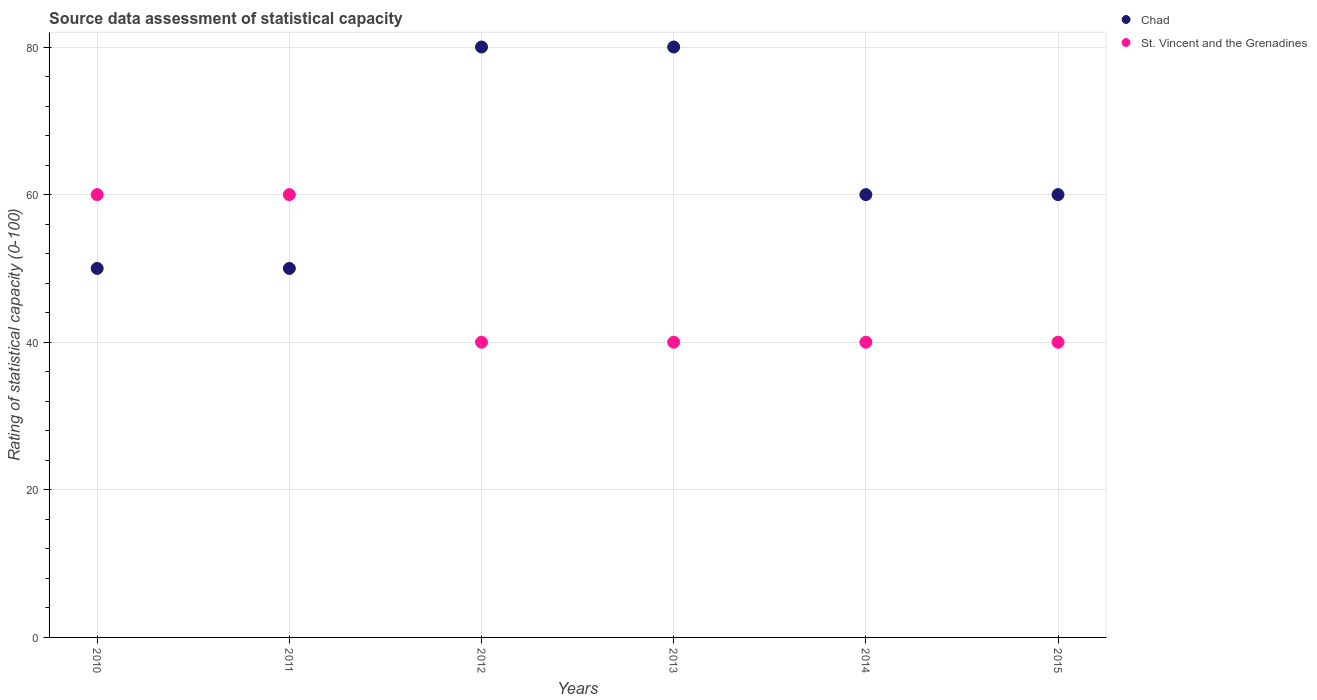Is the number of dotlines equal to the number of legend labels?
Give a very brief answer. Yes. Across all years, what is the maximum rating of statistical capacity in Chad?
Offer a very short reply. 80. Across all years, what is the minimum rating of statistical capacity in Chad?
Make the answer very short. 50. In which year was the rating of statistical capacity in St. Vincent and the Grenadines maximum?
Give a very brief answer. 2010. In which year was the rating of statistical capacity in St. Vincent and the Grenadines minimum?
Give a very brief answer. 2012. What is the total rating of statistical capacity in Chad in the graph?
Give a very brief answer. 380. What is the difference between the rating of statistical capacity in Chad in 2010 and that in 2012?
Offer a terse response. -30. What is the difference between the rating of statistical capacity in St. Vincent and the Grenadines in 2011 and the rating of statistical capacity in Chad in 2010?
Provide a short and direct response. 10. What is the average rating of statistical capacity in Chad per year?
Ensure brevity in your answer.  63.33. In the year 2012, what is the difference between the rating of statistical capacity in Chad and rating of statistical capacity in St. Vincent and the Grenadines?
Ensure brevity in your answer.  40. What is the ratio of the rating of statistical capacity in Chad in 2011 to that in 2015?
Ensure brevity in your answer.  0.83. Is the difference between the rating of statistical capacity in Chad in 2011 and 2013 greater than the difference between the rating of statistical capacity in St. Vincent and the Grenadines in 2011 and 2013?
Keep it short and to the point. No. What is the difference between the highest and the second highest rating of statistical capacity in Chad?
Your response must be concise. 0. What is the difference between the highest and the lowest rating of statistical capacity in Chad?
Make the answer very short. 30. Is the sum of the rating of statistical capacity in Chad in 2013 and 2014 greater than the maximum rating of statistical capacity in St. Vincent and the Grenadines across all years?
Offer a terse response. Yes. Does the rating of statistical capacity in St. Vincent and the Grenadines monotonically increase over the years?
Your answer should be very brief. No. Is the rating of statistical capacity in Chad strictly greater than the rating of statistical capacity in St. Vincent and the Grenadines over the years?
Keep it short and to the point. No. Does the graph contain any zero values?
Provide a succinct answer. No. Where does the legend appear in the graph?
Your answer should be very brief. Top right. What is the title of the graph?
Give a very brief answer. Source data assessment of statistical capacity. Does "Dominican Republic" appear as one of the legend labels in the graph?
Offer a very short reply. No. What is the label or title of the Y-axis?
Offer a very short reply. Rating of statistical capacity (0-100). What is the Rating of statistical capacity (0-100) in St. Vincent and the Grenadines in 2010?
Ensure brevity in your answer.  60. What is the Rating of statistical capacity (0-100) of Chad in 2011?
Keep it short and to the point. 50. What is the Rating of statistical capacity (0-100) in St. Vincent and the Grenadines in 2012?
Your answer should be very brief. 40. What is the Rating of statistical capacity (0-100) in St. Vincent and the Grenadines in 2013?
Offer a terse response. 40. What is the Rating of statistical capacity (0-100) of Chad in 2014?
Provide a short and direct response. 60. What is the Rating of statistical capacity (0-100) of St. Vincent and the Grenadines in 2014?
Your response must be concise. 40. What is the Rating of statistical capacity (0-100) of St. Vincent and the Grenadines in 2015?
Give a very brief answer. 40. Across all years, what is the maximum Rating of statistical capacity (0-100) in Chad?
Your answer should be very brief. 80. Across all years, what is the minimum Rating of statistical capacity (0-100) of St. Vincent and the Grenadines?
Your response must be concise. 40. What is the total Rating of statistical capacity (0-100) of Chad in the graph?
Your answer should be compact. 380. What is the total Rating of statistical capacity (0-100) of St. Vincent and the Grenadines in the graph?
Provide a short and direct response. 280. What is the difference between the Rating of statistical capacity (0-100) of St. Vincent and the Grenadines in 2010 and that in 2011?
Provide a succinct answer. 0. What is the difference between the Rating of statistical capacity (0-100) in St. Vincent and the Grenadines in 2010 and that in 2012?
Give a very brief answer. 20. What is the difference between the Rating of statistical capacity (0-100) of Chad in 2010 and that in 2013?
Your answer should be very brief. -30. What is the difference between the Rating of statistical capacity (0-100) of Chad in 2010 and that in 2014?
Offer a terse response. -10. What is the difference between the Rating of statistical capacity (0-100) of Chad in 2010 and that in 2015?
Your response must be concise. -10. What is the difference between the Rating of statistical capacity (0-100) of Chad in 2011 and that in 2014?
Keep it short and to the point. -10. What is the difference between the Rating of statistical capacity (0-100) of St. Vincent and the Grenadines in 2011 and that in 2014?
Your response must be concise. 20. What is the difference between the Rating of statistical capacity (0-100) in Chad in 2011 and that in 2015?
Ensure brevity in your answer.  -10. What is the difference between the Rating of statistical capacity (0-100) of St. Vincent and the Grenadines in 2012 and that in 2014?
Your answer should be very brief. 0. What is the difference between the Rating of statistical capacity (0-100) of Chad in 2012 and that in 2015?
Ensure brevity in your answer.  20. What is the difference between the Rating of statistical capacity (0-100) of St. Vincent and the Grenadines in 2013 and that in 2015?
Your answer should be very brief. 0. What is the difference between the Rating of statistical capacity (0-100) of St. Vincent and the Grenadines in 2014 and that in 2015?
Make the answer very short. 0. What is the difference between the Rating of statistical capacity (0-100) of Chad in 2010 and the Rating of statistical capacity (0-100) of St. Vincent and the Grenadines in 2011?
Ensure brevity in your answer.  -10. What is the difference between the Rating of statistical capacity (0-100) of Chad in 2010 and the Rating of statistical capacity (0-100) of St. Vincent and the Grenadines in 2015?
Offer a terse response. 10. What is the difference between the Rating of statistical capacity (0-100) of Chad in 2011 and the Rating of statistical capacity (0-100) of St. Vincent and the Grenadines in 2012?
Your answer should be very brief. 10. What is the difference between the Rating of statistical capacity (0-100) in Chad in 2011 and the Rating of statistical capacity (0-100) in St. Vincent and the Grenadines in 2015?
Ensure brevity in your answer.  10. What is the difference between the Rating of statistical capacity (0-100) in Chad in 2013 and the Rating of statistical capacity (0-100) in St. Vincent and the Grenadines in 2015?
Ensure brevity in your answer.  40. What is the difference between the Rating of statistical capacity (0-100) in Chad in 2014 and the Rating of statistical capacity (0-100) in St. Vincent and the Grenadines in 2015?
Keep it short and to the point. 20. What is the average Rating of statistical capacity (0-100) in Chad per year?
Your answer should be very brief. 63.33. What is the average Rating of statistical capacity (0-100) in St. Vincent and the Grenadines per year?
Offer a terse response. 46.67. In the year 2011, what is the difference between the Rating of statistical capacity (0-100) in Chad and Rating of statistical capacity (0-100) in St. Vincent and the Grenadines?
Your response must be concise. -10. In the year 2012, what is the difference between the Rating of statistical capacity (0-100) in Chad and Rating of statistical capacity (0-100) in St. Vincent and the Grenadines?
Your answer should be very brief. 40. In the year 2015, what is the difference between the Rating of statistical capacity (0-100) of Chad and Rating of statistical capacity (0-100) of St. Vincent and the Grenadines?
Give a very brief answer. 20. What is the ratio of the Rating of statistical capacity (0-100) in Chad in 2010 to that in 2011?
Your response must be concise. 1. What is the ratio of the Rating of statistical capacity (0-100) in St. Vincent and the Grenadines in 2010 to that in 2011?
Your answer should be compact. 1. What is the ratio of the Rating of statistical capacity (0-100) in Chad in 2010 to that in 2012?
Offer a very short reply. 0.62. What is the ratio of the Rating of statistical capacity (0-100) in St. Vincent and the Grenadines in 2010 to that in 2012?
Give a very brief answer. 1.5. What is the ratio of the Rating of statistical capacity (0-100) of Chad in 2010 to that in 2013?
Offer a terse response. 0.62. What is the ratio of the Rating of statistical capacity (0-100) of Chad in 2010 to that in 2014?
Give a very brief answer. 0.83. What is the ratio of the Rating of statistical capacity (0-100) in St. Vincent and the Grenadines in 2010 to that in 2015?
Provide a short and direct response. 1.5. What is the ratio of the Rating of statistical capacity (0-100) of St. Vincent and the Grenadines in 2011 to that in 2012?
Ensure brevity in your answer.  1.5. What is the ratio of the Rating of statistical capacity (0-100) of Chad in 2011 to that in 2013?
Your answer should be very brief. 0.62. What is the ratio of the Rating of statistical capacity (0-100) of St. Vincent and the Grenadines in 2011 to that in 2013?
Your answer should be very brief. 1.5. What is the ratio of the Rating of statistical capacity (0-100) in St. Vincent and the Grenadines in 2011 to that in 2014?
Provide a succinct answer. 1.5. What is the ratio of the Rating of statistical capacity (0-100) of Chad in 2011 to that in 2015?
Make the answer very short. 0.83. What is the ratio of the Rating of statistical capacity (0-100) of St. Vincent and the Grenadines in 2011 to that in 2015?
Your answer should be very brief. 1.5. What is the ratio of the Rating of statistical capacity (0-100) in St. Vincent and the Grenadines in 2012 to that in 2013?
Your answer should be very brief. 1. What is the ratio of the Rating of statistical capacity (0-100) in St. Vincent and the Grenadines in 2012 to that in 2015?
Offer a very short reply. 1. What is the ratio of the Rating of statistical capacity (0-100) of Chad in 2013 to that in 2014?
Your answer should be compact. 1.33. What is the ratio of the Rating of statistical capacity (0-100) of St. Vincent and the Grenadines in 2013 to that in 2014?
Make the answer very short. 1. What is the ratio of the Rating of statistical capacity (0-100) of Chad in 2013 to that in 2015?
Offer a very short reply. 1.33. What is the ratio of the Rating of statistical capacity (0-100) of Chad in 2014 to that in 2015?
Give a very brief answer. 1. What is the ratio of the Rating of statistical capacity (0-100) of St. Vincent and the Grenadines in 2014 to that in 2015?
Give a very brief answer. 1. What is the difference between the highest and the second highest Rating of statistical capacity (0-100) in St. Vincent and the Grenadines?
Offer a very short reply. 0. What is the difference between the highest and the lowest Rating of statistical capacity (0-100) in Chad?
Offer a terse response. 30. What is the difference between the highest and the lowest Rating of statistical capacity (0-100) of St. Vincent and the Grenadines?
Provide a succinct answer. 20. 